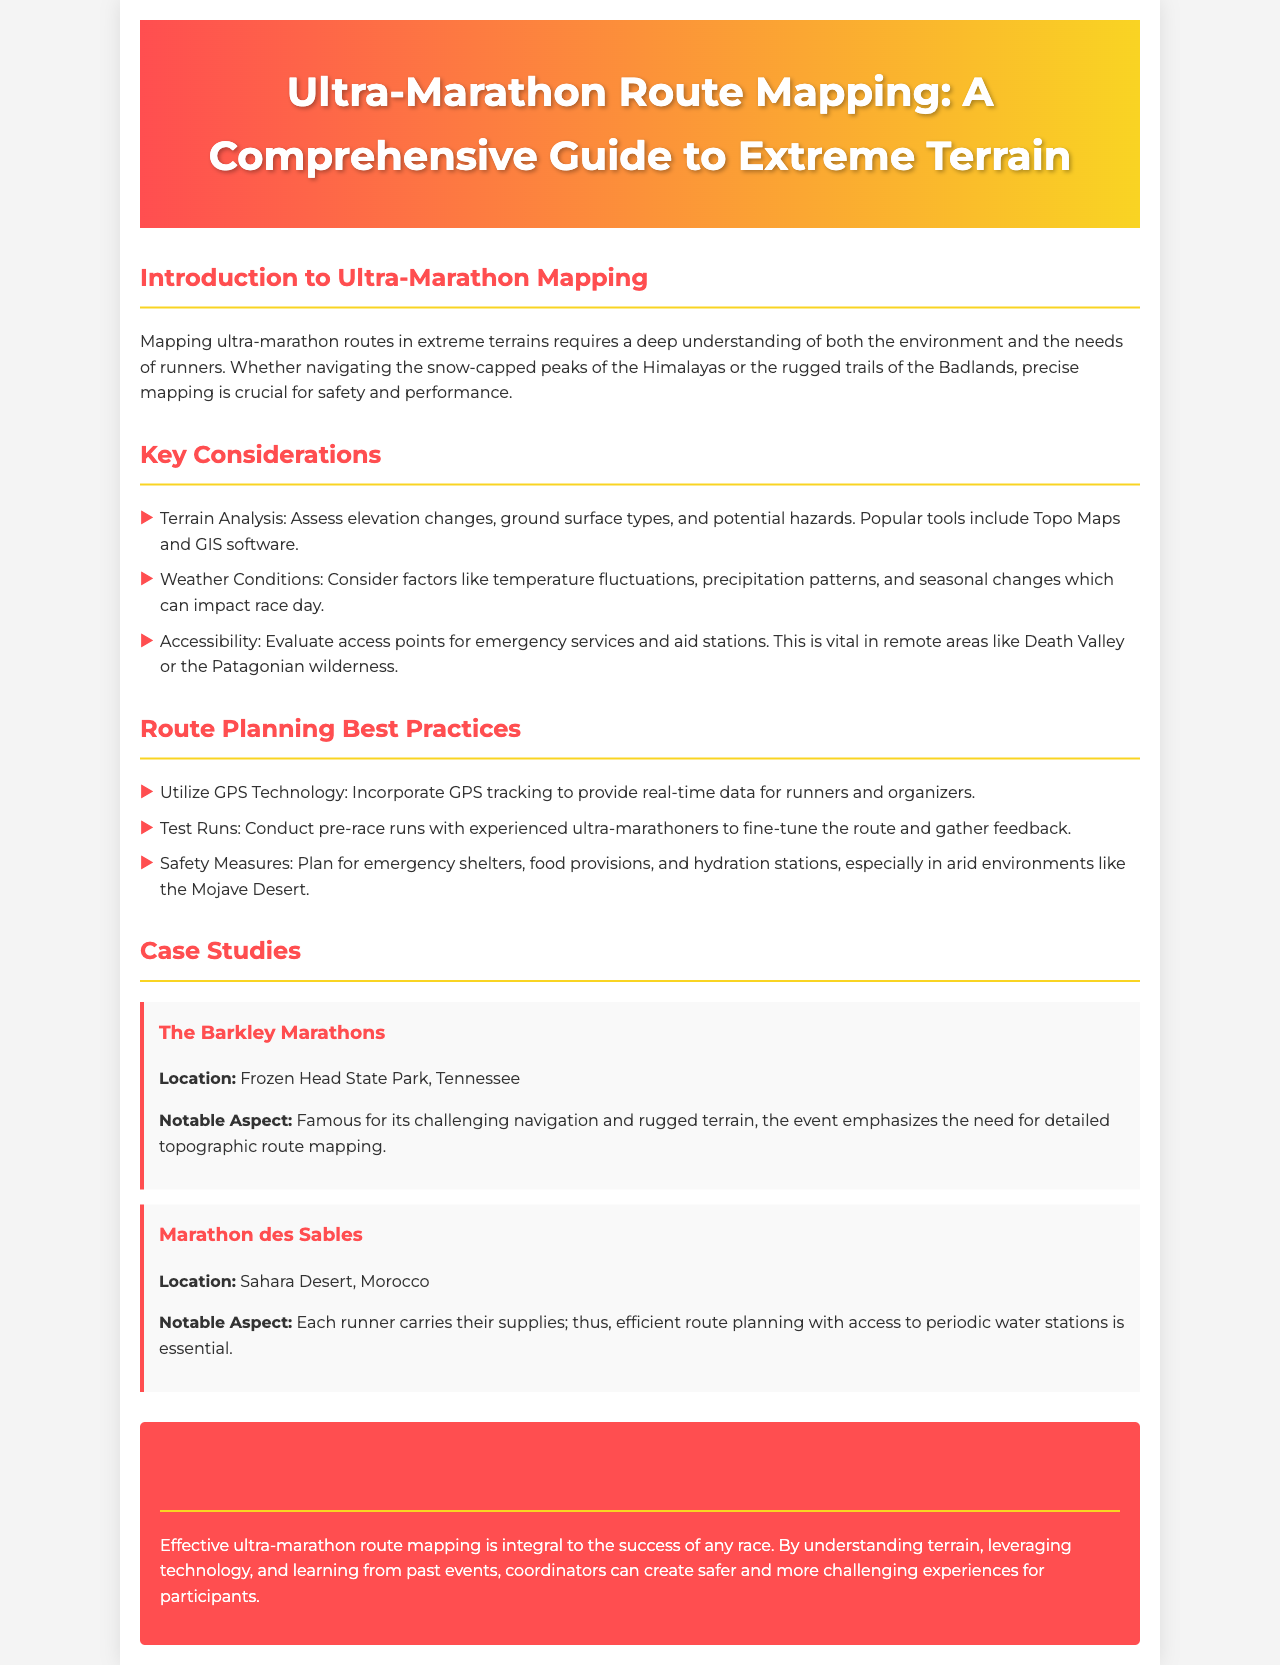What is the title of the guide? The title of the guide is given at the top of the document as part of the header.
Answer: Ultra-Marathon Route Mapping: A Comprehensive Guide to Extreme Terrain What are the three key considerations mentioned? The document lists key considerations in a bulleted format under the section "Key Considerations."
Answer: Terrain Analysis, Weather Conditions, Accessibility Where is the Barkley Marathons located? The location of the Barkley Marathons is specified in the case study section of the document.
Answer: Frozen Head State Park, Tennessee What technology should be utilized for route planning? The guide mentions a specific technology in the "Route Planning Best Practices" section.
Answer: GPS Technology What is a notable aspect of the Marathon des Sables? The document highlights specific aspects of the event in the case study.
Answer: Each runner carries their supplies What is the primary goal of effective ultra-marathon route mapping? The conclusion section emphasizes the main objective of mapping for ultra-marathons.
Answer: Safety and performance Which desert is mentioned in the context of safety measures? The document references a specific desert environment in discussing safety measures in route planning.
Answer: Mojave Desert How are emergency services evaluated according to the guide? The document discusses evaluating access points for a specific reason in the "Key Considerations" section.
Answer: Accessibility 